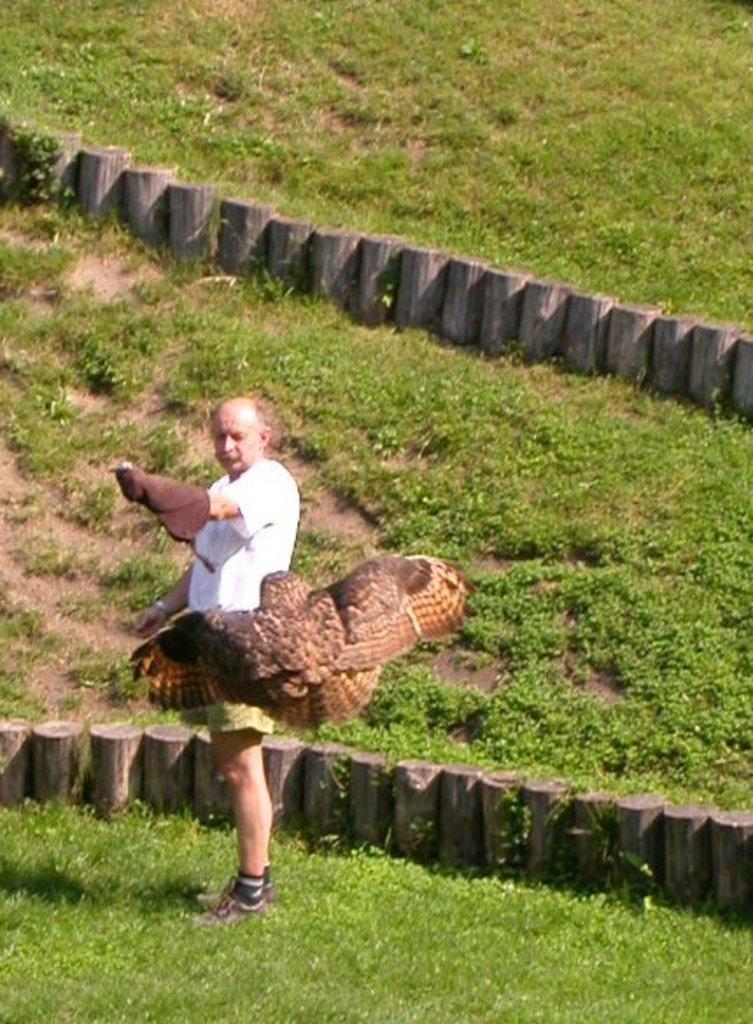What is the main subject of the image? The main subject of the image is a man standing. What type of vegetation can be seen in the image? There are green color plants in the image. What is the natural setting visible in the image? The natural setting includes woods. What type of truck can be seen driving through the woods in the image? There is no truck present in the image; it only features a man standing and green color plants. What type of shock can be felt while walking through the woods in the image? The image does not convey any tactile sensations, such as a shock, while walking through the woods. 